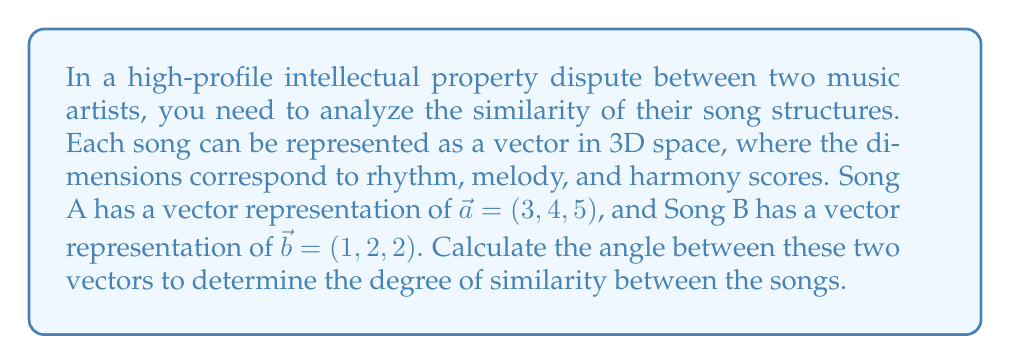Provide a solution to this math problem. To find the angle between two vectors in 3D space, we can use the dot product formula:

$$\cos \theta = \frac{\vec{a} \cdot \vec{b}}{|\vec{a}| |\vec{b}|}$$

Where $\theta$ is the angle between the vectors, $\vec{a} \cdot \vec{b}$ is the dot product of the vectors, and $|\vec{a}|$ and $|\vec{b}|$ are the magnitudes of the vectors.

Step 1: Calculate the dot product $\vec{a} \cdot \vec{b}$
$$\vec{a} \cdot \vec{b} = (3)(1) + (4)(2) + (5)(2) = 3 + 8 + 10 = 21$$

Step 2: Calculate the magnitudes of the vectors
$$|\vec{a}| = \sqrt{3^2 + 4^2 + 5^2} = \sqrt{9 + 16 + 25} = \sqrt{50}$$
$$|\vec{b}| = \sqrt{1^2 + 2^2 + 2^2} = \sqrt{1 + 4 + 4} = 3$$

Step 3: Substitute into the formula
$$\cos \theta = \frac{21}{(\sqrt{50})(3)}$$

Step 4: Simplify
$$\cos \theta = \frac{21}{3\sqrt{50}} = \frac{7}{\sqrt{50}}$$

Step 5: Take the inverse cosine (arccos) of both sides
$$\theta = \arccos\left(\frac{7}{\sqrt{50}}\right)$$

Step 6: Calculate the final answer (in radians, then convert to degrees)
$$\theta \approx 0.7048 \text{ radians}$$
$$\theta \approx 40.37°$$
Answer: The angle between the two vectors representing the songs is approximately 40.37°. 